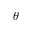<formula> <loc_0><loc_0><loc_500><loc_500>\theta</formula> 